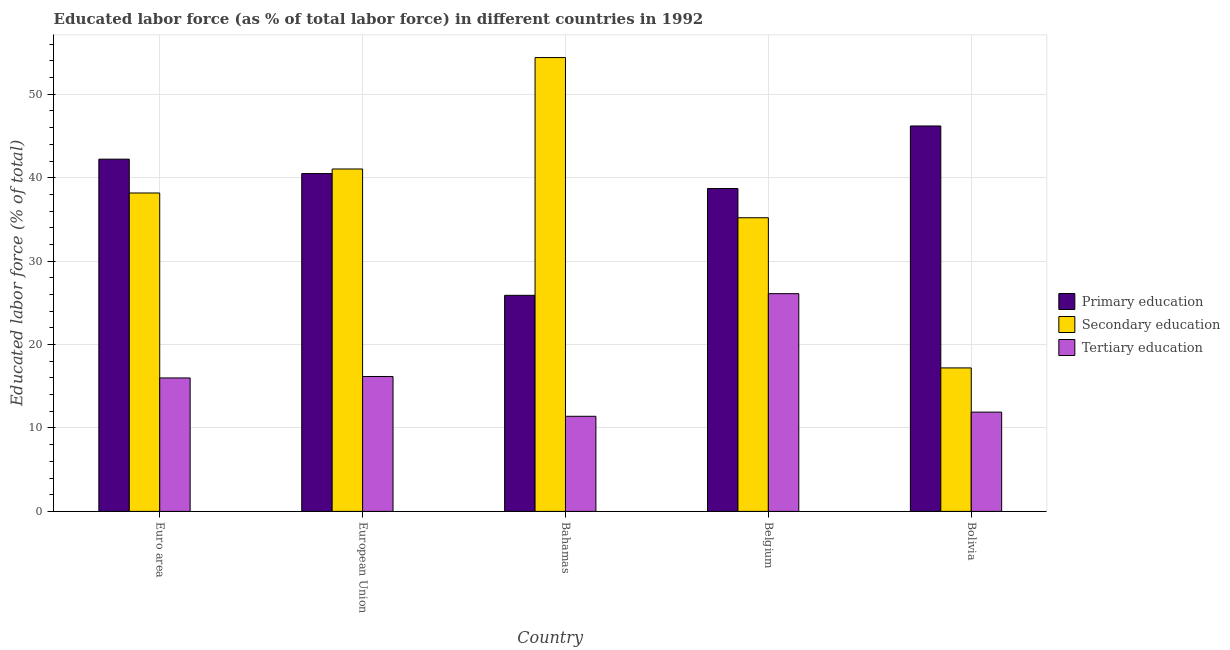How many groups of bars are there?
Keep it short and to the point. 5. Are the number of bars per tick equal to the number of legend labels?
Your response must be concise. Yes. Are the number of bars on each tick of the X-axis equal?
Offer a very short reply. Yes. How many bars are there on the 4th tick from the left?
Ensure brevity in your answer.  3. How many bars are there on the 1st tick from the right?
Keep it short and to the point. 3. What is the label of the 5th group of bars from the left?
Ensure brevity in your answer.  Bolivia. In how many cases, is the number of bars for a given country not equal to the number of legend labels?
Your answer should be compact. 0. What is the percentage of labor force who received tertiary education in Belgium?
Keep it short and to the point. 26.1. Across all countries, what is the maximum percentage of labor force who received primary education?
Provide a succinct answer. 46.2. Across all countries, what is the minimum percentage of labor force who received tertiary education?
Provide a succinct answer. 11.4. In which country was the percentage of labor force who received secondary education maximum?
Make the answer very short. Bahamas. In which country was the percentage of labor force who received primary education minimum?
Your answer should be compact. Bahamas. What is the total percentage of labor force who received primary education in the graph?
Give a very brief answer. 193.52. What is the difference between the percentage of labor force who received tertiary education in Euro area and that in European Union?
Provide a succinct answer. -0.18. What is the difference between the percentage of labor force who received tertiary education in Bahamas and the percentage of labor force who received primary education in Belgium?
Keep it short and to the point. -27.3. What is the average percentage of labor force who received primary education per country?
Give a very brief answer. 38.7. What is the difference between the percentage of labor force who received tertiary education and percentage of labor force who received primary education in Belgium?
Give a very brief answer. -12.6. What is the ratio of the percentage of labor force who received tertiary education in Euro area to that in European Union?
Provide a short and direct response. 0.99. Is the percentage of labor force who received tertiary education in Belgium less than that in European Union?
Offer a very short reply. No. What is the difference between the highest and the second highest percentage of labor force who received tertiary education?
Give a very brief answer. 9.93. What is the difference between the highest and the lowest percentage of labor force who received tertiary education?
Your answer should be very brief. 14.7. Is the sum of the percentage of labor force who received secondary education in Bolivia and European Union greater than the maximum percentage of labor force who received primary education across all countries?
Provide a succinct answer. Yes. What does the 2nd bar from the left in Belgium represents?
Offer a terse response. Secondary education. What does the 3rd bar from the right in European Union represents?
Provide a succinct answer. Primary education. How many bars are there?
Ensure brevity in your answer.  15. Does the graph contain any zero values?
Your answer should be compact. No. Does the graph contain grids?
Your answer should be very brief. Yes. Where does the legend appear in the graph?
Your response must be concise. Center right. How are the legend labels stacked?
Offer a very short reply. Vertical. What is the title of the graph?
Make the answer very short. Educated labor force (as % of total labor force) in different countries in 1992. Does "Taxes" appear as one of the legend labels in the graph?
Keep it short and to the point. No. What is the label or title of the X-axis?
Your answer should be very brief. Country. What is the label or title of the Y-axis?
Provide a succinct answer. Educated labor force (% of total). What is the Educated labor force (% of total) of Primary education in Euro area?
Ensure brevity in your answer.  42.22. What is the Educated labor force (% of total) in Secondary education in Euro area?
Your answer should be very brief. 38.17. What is the Educated labor force (% of total) in Tertiary education in Euro area?
Ensure brevity in your answer.  16. What is the Educated labor force (% of total) of Primary education in European Union?
Give a very brief answer. 40.49. What is the Educated labor force (% of total) of Secondary education in European Union?
Provide a succinct answer. 41.04. What is the Educated labor force (% of total) in Tertiary education in European Union?
Provide a short and direct response. 16.17. What is the Educated labor force (% of total) of Primary education in Bahamas?
Offer a very short reply. 25.9. What is the Educated labor force (% of total) in Secondary education in Bahamas?
Your answer should be compact. 54.4. What is the Educated labor force (% of total) of Tertiary education in Bahamas?
Make the answer very short. 11.4. What is the Educated labor force (% of total) in Primary education in Belgium?
Make the answer very short. 38.7. What is the Educated labor force (% of total) in Secondary education in Belgium?
Ensure brevity in your answer.  35.2. What is the Educated labor force (% of total) in Tertiary education in Belgium?
Offer a terse response. 26.1. What is the Educated labor force (% of total) in Primary education in Bolivia?
Give a very brief answer. 46.2. What is the Educated labor force (% of total) of Secondary education in Bolivia?
Your response must be concise. 17.2. What is the Educated labor force (% of total) in Tertiary education in Bolivia?
Give a very brief answer. 11.9. Across all countries, what is the maximum Educated labor force (% of total) in Primary education?
Give a very brief answer. 46.2. Across all countries, what is the maximum Educated labor force (% of total) in Secondary education?
Keep it short and to the point. 54.4. Across all countries, what is the maximum Educated labor force (% of total) in Tertiary education?
Provide a succinct answer. 26.1. Across all countries, what is the minimum Educated labor force (% of total) in Primary education?
Offer a very short reply. 25.9. Across all countries, what is the minimum Educated labor force (% of total) in Secondary education?
Your answer should be very brief. 17.2. Across all countries, what is the minimum Educated labor force (% of total) in Tertiary education?
Ensure brevity in your answer.  11.4. What is the total Educated labor force (% of total) of Primary education in the graph?
Give a very brief answer. 193.52. What is the total Educated labor force (% of total) of Secondary education in the graph?
Provide a short and direct response. 186.01. What is the total Educated labor force (% of total) in Tertiary education in the graph?
Your response must be concise. 81.57. What is the difference between the Educated labor force (% of total) of Primary education in Euro area and that in European Union?
Your response must be concise. 1.73. What is the difference between the Educated labor force (% of total) of Secondary education in Euro area and that in European Union?
Make the answer very short. -2.88. What is the difference between the Educated labor force (% of total) of Tertiary education in Euro area and that in European Union?
Your answer should be very brief. -0.18. What is the difference between the Educated labor force (% of total) in Primary education in Euro area and that in Bahamas?
Keep it short and to the point. 16.32. What is the difference between the Educated labor force (% of total) in Secondary education in Euro area and that in Bahamas?
Make the answer very short. -16.23. What is the difference between the Educated labor force (% of total) of Tertiary education in Euro area and that in Bahamas?
Make the answer very short. 4.6. What is the difference between the Educated labor force (% of total) of Primary education in Euro area and that in Belgium?
Keep it short and to the point. 3.52. What is the difference between the Educated labor force (% of total) of Secondary education in Euro area and that in Belgium?
Offer a terse response. 2.97. What is the difference between the Educated labor force (% of total) in Tertiary education in Euro area and that in Belgium?
Your answer should be very brief. -10.1. What is the difference between the Educated labor force (% of total) in Primary education in Euro area and that in Bolivia?
Provide a succinct answer. -3.98. What is the difference between the Educated labor force (% of total) of Secondary education in Euro area and that in Bolivia?
Your answer should be very brief. 20.97. What is the difference between the Educated labor force (% of total) of Tertiary education in Euro area and that in Bolivia?
Your answer should be compact. 4.1. What is the difference between the Educated labor force (% of total) of Primary education in European Union and that in Bahamas?
Offer a very short reply. 14.59. What is the difference between the Educated labor force (% of total) of Secondary education in European Union and that in Bahamas?
Keep it short and to the point. -13.36. What is the difference between the Educated labor force (% of total) of Tertiary education in European Union and that in Bahamas?
Your answer should be very brief. 4.77. What is the difference between the Educated labor force (% of total) of Primary education in European Union and that in Belgium?
Provide a short and direct response. 1.79. What is the difference between the Educated labor force (% of total) of Secondary education in European Union and that in Belgium?
Keep it short and to the point. 5.84. What is the difference between the Educated labor force (% of total) of Tertiary education in European Union and that in Belgium?
Your answer should be compact. -9.93. What is the difference between the Educated labor force (% of total) of Primary education in European Union and that in Bolivia?
Keep it short and to the point. -5.71. What is the difference between the Educated labor force (% of total) in Secondary education in European Union and that in Bolivia?
Your answer should be very brief. 23.84. What is the difference between the Educated labor force (% of total) of Tertiary education in European Union and that in Bolivia?
Offer a terse response. 4.27. What is the difference between the Educated labor force (% of total) of Primary education in Bahamas and that in Belgium?
Offer a very short reply. -12.8. What is the difference between the Educated labor force (% of total) of Secondary education in Bahamas and that in Belgium?
Give a very brief answer. 19.2. What is the difference between the Educated labor force (% of total) of Tertiary education in Bahamas and that in Belgium?
Your response must be concise. -14.7. What is the difference between the Educated labor force (% of total) of Primary education in Bahamas and that in Bolivia?
Your answer should be compact. -20.3. What is the difference between the Educated labor force (% of total) in Secondary education in Bahamas and that in Bolivia?
Provide a short and direct response. 37.2. What is the difference between the Educated labor force (% of total) of Primary education in Belgium and that in Bolivia?
Provide a short and direct response. -7.5. What is the difference between the Educated labor force (% of total) in Secondary education in Belgium and that in Bolivia?
Offer a terse response. 18. What is the difference between the Educated labor force (% of total) of Tertiary education in Belgium and that in Bolivia?
Ensure brevity in your answer.  14.2. What is the difference between the Educated labor force (% of total) of Primary education in Euro area and the Educated labor force (% of total) of Secondary education in European Union?
Offer a very short reply. 1.18. What is the difference between the Educated labor force (% of total) in Primary education in Euro area and the Educated labor force (% of total) in Tertiary education in European Union?
Offer a terse response. 26.05. What is the difference between the Educated labor force (% of total) in Secondary education in Euro area and the Educated labor force (% of total) in Tertiary education in European Union?
Provide a succinct answer. 22. What is the difference between the Educated labor force (% of total) in Primary education in Euro area and the Educated labor force (% of total) in Secondary education in Bahamas?
Offer a terse response. -12.18. What is the difference between the Educated labor force (% of total) of Primary education in Euro area and the Educated labor force (% of total) of Tertiary education in Bahamas?
Provide a short and direct response. 30.82. What is the difference between the Educated labor force (% of total) in Secondary education in Euro area and the Educated labor force (% of total) in Tertiary education in Bahamas?
Offer a very short reply. 26.77. What is the difference between the Educated labor force (% of total) of Primary education in Euro area and the Educated labor force (% of total) of Secondary education in Belgium?
Your answer should be very brief. 7.02. What is the difference between the Educated labor force (% of total) in Primary education in Euro area and the Educated labor force (% of total) in Tertiary education in Belgium?
Your answer should be very brief. 16.12. What is the difference between the Educated labor force (% of total) in Secondary education in Euro area and the Educated labor force (% of total) in Tertiary education in Belgium?
Provide a succinct answer. 12.07. What is the difference between the Educated labor force (% of total) in Primary education in Euro area and the Educated labor force (% of total) in Secondary education in Bolivia?
Offer a very short reply. 25.02. What is the difference between the Educated labor force (% of total) of Primary education in Euro area and the Educated labor force (% of total) of Tertiary education in Bolivia?
Give a very brief answer. 30.32. What is the difference between the Educated labor force (% of total) of Secondary education in Euro area and the Educated labor force (% of total) of Tertiary education in Bolivia?
Offer a very short reply. 26.27. What is the difference between the Educated labor force (% of total) in Primary education in European Union and the Educated labor force (% of total) in Secondary education in Bahamas?
Your answer should be compact. -13.91. What is the difference between the Educated labor force (% of total) of Primary education in European Union and the Educated labor force (% of total) of Tertiary education in Bahamas?
Offer a very short reply. 29.09. What is the difference between the Educated labor force (% of total) of Secondary education in European Union and the Educated labor force (% of total) of Tertiary education in Bahamas?
Your answer should be very brief. 29.64. What is the difference between the Educated labor force (% of total) of Primary education in European Union and the Educated labor force (% of total) of Secondary education in Belgium?
Offer a terse response. 5.29. What is the difference between the Educated labor force (% of total) in Primary education in European Union and the Educated labor force (% of total) in Tertiary education in Belgium?
Give a very brief answer. 14.39. What is the difference between the Educated labor force (% of total) in Secondary education in European Union and the Educated labor force (% of total) in Tertiary education in Belgium?
Your answer should be compact. 14.94. What is the difference between the Educated labor force (% of total) in Primary education in European Union and the Educated labor force (% of total) in Secondary education in Bolivia?
Give a very brief answer. 23.29. What is the difference between the Educated labor force (% of total) in Primary education in European Union and the Educated labor force (% of total) in Tertiary education in Bolivia?
Provide a succinct answer. 28.59. What is the difference between the Educated labor force (% of total) in Secondary education in European Union and the Educated labor force (% of total) in Tertiary education in Bolivia?
Keep it short and to the point. 29.14. What is the difference between the Educated labor force (% of total) in Secondary education in Bahamas and the Educated labor force (% of total) in Tertiary education in Belgium?
Provide a succinct answer. 28.3. What is the difference between the Educated labor force (% of total) of Secondary education in Bahamas and the Educated labor force (% of total) of Tertiary education in Bolivia?
Ensure brevity in your answer.  42.5. What is the difference between the Educated labor force (% of total) of Primary education in Belgium and the Educated labor force (% of total) of Secondary education in Bolivia?
Offer a very short reply. 21.5. What is the difference between the Educated labor force (% of total) in Primary education in Belgium and the Educated labor force (% of total) in Tertiary education in Bolivia?
Give a very brief answer. 26.8. What is the difference between the Educated labor force (% of total) of Secondary education in Belgium and the Educated labor force (% of total) of Tertiary education in Bolivia?
Provide a short and direct response. 23.3. What is the average Educated labor force (% of total) in Primary education per country?
Keep it short and to the point. 38.7. What is the average Educated labor force (% of total) in Secondary education per country?
Provide a succinct answer. 37.2. What is the average Educated labor force (% of total) of Tertiary education per country?
Provide a succinct answer. 16.31. What is the difference between the Educated labor force (% of total) of Primary education and Educated labor force (% of total) of Secondary education in Euro area?
Offer a terse response. 4.05. What is the difference between the Educated labor force (% of total) in Primary education and Educated labor force (% of total) in Tertiary education in Euro area?
Keep it short and to the point. 26.23. What is the difference between the Educated labor force (% of total) in Secondary education and Educated labor force (% of total) in Tertiary education in Euro area?
Your answer should be compact. 22.17. What is the difference between the Educated labor force (% of total) of Primary education and Educated labor force (% of total) of Secondary education in European Union?
Offer a very short reply. -0.55. What is the difference between the Educated labor force (% of total) of Primary education and Educated labor force (% of total) of Tertiary education in European Union?
Your response must be concise. 24.32. What is the difference between the Educated labor force (% of total) of Secondary education and Educated labor force (% of total) of Tertiary education in European Union?
Offer a very short reply. 24.87. What is the difference between the Educated labor force (% of total) in Primary education and Educated labor force (% of total) in Secondary education in Bahamas?
Offer a terse response. -28.5. What is the difference between the Educated labor force (% of total) in Primary education and Educated labor force (% of total) in Tertiary education in Bahamas?
Your answer should be compact. 14.5. What is the difference between the Educated labor force (% of total) of Secondary education and Educated labor force (% of total) of Tertiary education in Bahamas?
Make the answer very short. 43. What is the difference between the Educated labor force (% of total) of Primary education and Educated labor force (% of total) of Secondary education in Belgium?
Provide a succinct answer. 3.5. What is the difference between the Educated labor force (% of total) of Primary education and Educated labor force (% of total) of Tertiary education in Belgium?
Your response must be concise. 12.6. What is the difference between the Educated labor force (% of total) in Secondary education and Educated labor force (% of total) in Tertiary education in Belgium?
Provide a short and direct response. 9.1. What is the difference between the Educated labor force (% of total) in Primary education and Educated labor force (% of total) in Secondary education in Bolivia?
Give a very brief answer. 29. What is the difference between the Educated labor force (% of total) in Primary education and Educated labor force (% of total) in Tertiary education in Bolivia?
Provide a succinct answer. 34.3. What is the ratio of the Educated labor force (% of total) of Primary education in Euro area to that in European Union?
Offer a very short reply. 1.04. What is the ratio of the Educated labor force (% of total) of Secondary education in Euro area to that in European Union?
Your answer should be compact. 0.93. What is the ratio of the Educated labor force (% of total) in Tertiary education in Euro area to that in European Union?
Ensure brevity in your answer.  0.99. What is the ratio of the Educated labor force (% of total) in Primary education in Euro area to that in Bahamas?
Offer a terse response. 1.63. What is the ratio of the Educated labor force (% of total) in Secondary education in Euro area to that in Bahamas?
Your answer should be very brief. 0.7. What is the ratio of the Educated labor force (% of total) of Tertiary education in Euro area to that in Bahamas?
Make the answer very short. 1.4. What is the ratio of the Educated labor force (% of total) in Primary education in Euro area to that in Belgium?
Provide a short and direct response. 1.09. What is the ratio of the Educated labor force (% of total) in Secondary education in Euro area to that in Belgium?
Your response must be concise. 1.08. What is the ratio of the Educated labor force (% of total) in Tertiary education in Euro area to that in Belgium?
Offer a very short reply. 0.61. What is the ratio of the Educated labor force (% of total) of Primary education in Euro area to that in Bolivia?
Your answer should be very brief. 0.91. What is the ratio of the Educated labor force (% of total) of Secondary education in Euro area to that in Bolivia?
Provide a short and direct response. 2.22. What is the ratio of the Educated labor force (% of total) of Tertiary education in Euro area to that in Bolivia?
Provide a succinct answer. 1.34. What is the ratio of the Educated labor force (% of total) of Primary education in European Union to that in Bahamas?
Offer a terse response. 1.56. What is the ratio of the Educated labor force (% of total) in Secondary education in European Union to that in Bahamas?
Offer a very short reply. 0.75. What is the ratio of the Educated labor force (% of total) of Tertiary education in European Union to that in Bahamas?
Provide a succinct answer. 1.42. What is the ratio of the Educated labor force (% of total) in Primary education in European Union to that in Belgium?
Your answer should be very brief. 1.05. What is the ratio of the Educated labor force (% of total) in Secondary education in European Union to that in Belgium?
Keep it short and to the point. 1.17. What is the ratio of the Educated labor force (% of total) in Tertiary education in European Union to that in Belgium?
Keep it short and to the point. 0.62. What is the ratio of the Educated labor force (% of total) of Primary education in European Union to that in Bolivia?
Offer a very short reply. 0.88. What is the ratio of the Educated labor force (% of total) of Secondary education in European Union to that in Bolivia?
Offer a terse response. 2.39. What is the ratio of the Educated labor force (% of total) of Tertiary education in European Union to that in Bolivia?
Keep it short and to the point. 1.36. What is the ratio of the Educated labor force (% of total) in Primary education in Bahamas to that in Belgium?
Keep it short and to the point. 0.67. What is the ratio of the Educated labor force (% of total) of Secondary education in Bahamas to that in Belgium?
Your answer should be compact. 1.55. What is the ratio of the Educated labor force (% of total) of Tertiary education in Bahamas to that in Belgium?
Make the answer very short. 0.44. What is the ratio of the Educated labor force (% of total) in Primary education in Bahamas to that in Bolivia?
Make the answer very short. 0.56. What is the ratio of the Educated labor force (% of total) in Secondary education in Bahamas to that in Bolivia?
Give a very brief answer. 3.16. What is the ratio of the Educated labor force (% of total) in Tertiary education in Bahamas to that in Bolivia?
Your response must be concise. 0.96. What is the ratio of the Educated labor force (% of total) of Primary education in Belgium to that in Bolivia?
Provide a short and direct response. 0.84. What is the ratio of the Educated labor force (% of total) in Secondary education in Belgium to that in Bolivia?
Make the answer very short. 2.05. What is the ratio of the Educated labor force (% of total) in Tertiary education in Belgium to that in Bolivia?
Ensure brevity in your answer.  2.19. What is the difference between the highest and the second highest Educated labor force (% of total) of Primary education?
Offer a terse response. 3.98. What is the difference between the highest and the second highest Educated labor force (% of total) of Secondary education?
Give a very brief answer. 13.36. What is the difference between the highest and the second highest Educated labor force (% of total) of Tertiary education?
Give a very brief answer. 9.93. What is the difference between the highest and the lowest Educated labor force (% of total) of Primary education?
Your response must be concise. 20.3. What is the difference between the highest and the lowest Educated labor force (% of total) in Secondary education?
Give a very brief answer. 37.2. What is the difference between the highest and the lowest Educated labor force (% of total) of Tertiary education?
Offer a very short reply. 14.7. 